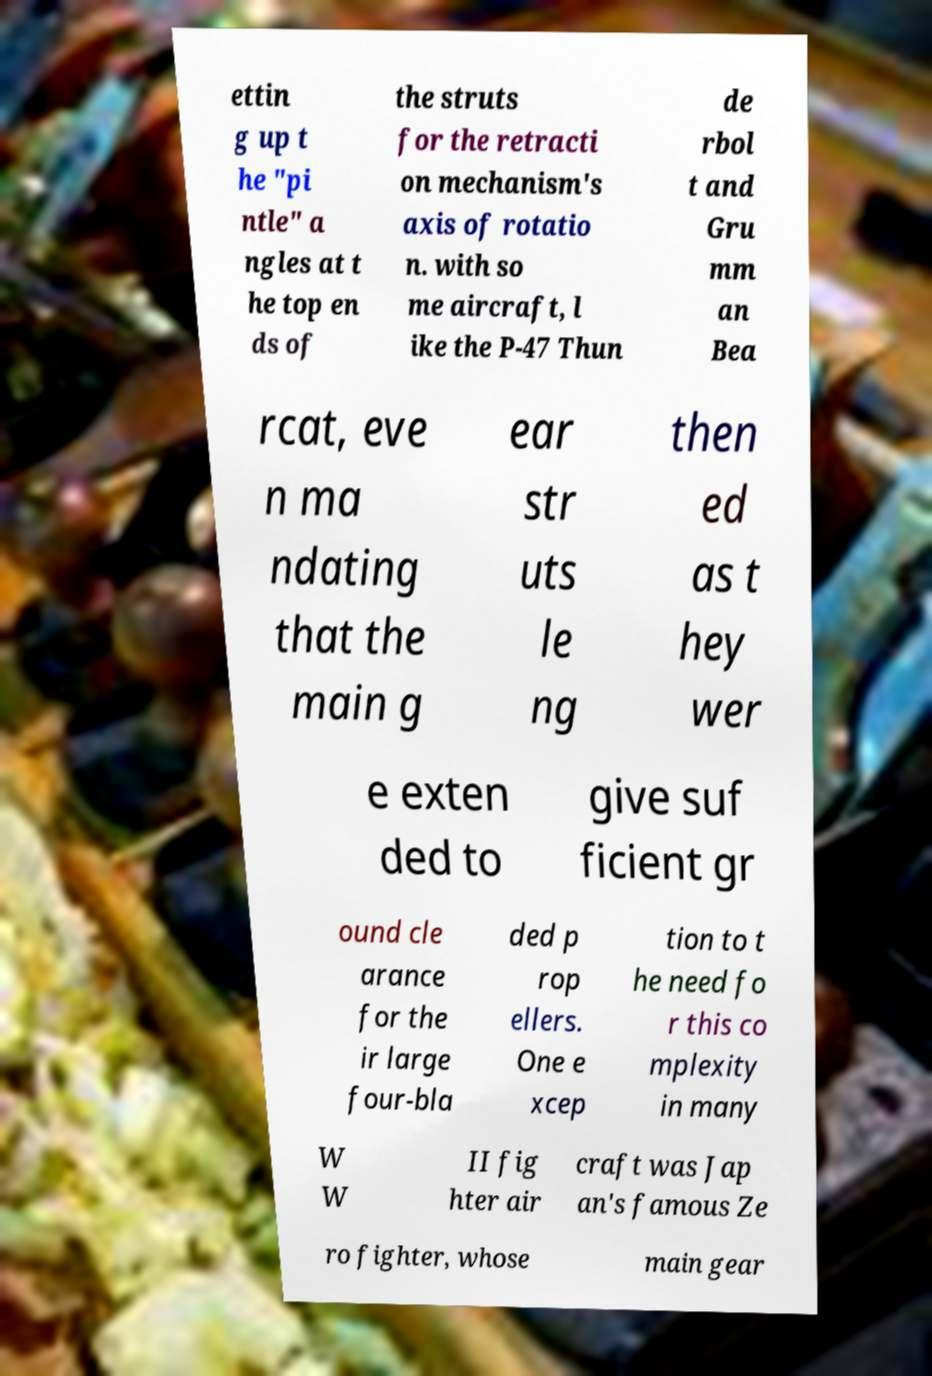I need the written content from this picture converted into text. Can you do that? ettin g up t he "pi ntle" a ngles at t he top en ds of the struts for the retracti on mechanism's axis of rotatio n. with so me aircraft, l ike the P-47 Thun de rbol t and Gru mm an Bea rcat, eve n ma ndating that the main g ear str uts le ng then ed as t hey wer e exten ded to give suf ficient gr ound cle arance for the ir large four-bla ded p rop ellers. One e xcep tion to t he need fo r this co mplexity in many W W II fig hter air craft was Jap an's famous Ze ro fighter, whose main gear 